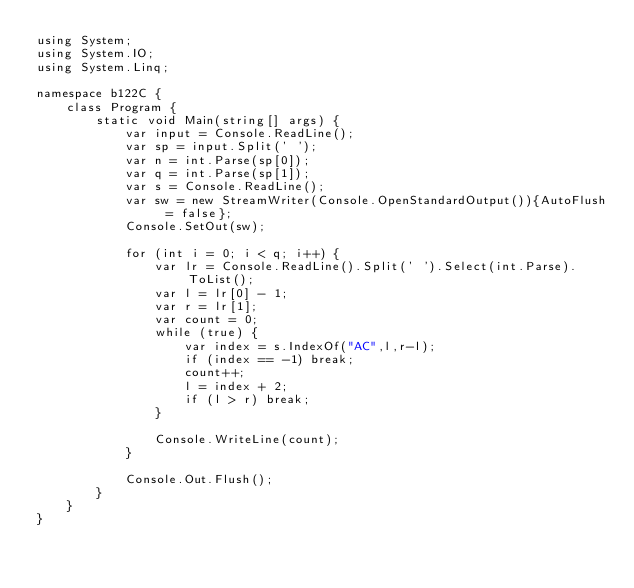Convert code to text. <code><loc_0><loc_0><loc_500><loc_500><_C#_>using System;
using System.IO;
using System.Linq;

namespace b122C {
    class Program {
        static void Main(string[] args) {
            var input = Console.ReadLine();
            var sp = input.Split(' ');
            var n = int.Parse(sp[0]);
            var q = int.Parse(sp[1]);
            var s = Console.ReadLine();
            var sw = new StreamWriter(Console.OpenStandardOutput()){AutoFlush = false};
            Console.SetOut(sw);

            for (int i = 0; i < q; i++) {
                var lr = Console.ReadLine().Split(' ').Select(int.Parse).ToList();
                var l = lr[0] - 1;
                var r = lr[1];
                var count = 0;
                while (true) {
                    var index = s.IndexOf("AC",l,r-l);
                    if (index == -1) break;
                    count++;
                    l = index + 2;
                    if (l > r) break;
                }

                Console.WriteLine(count);
            }
            
            Console.Out.Flush();
        }
    }
}</code> 